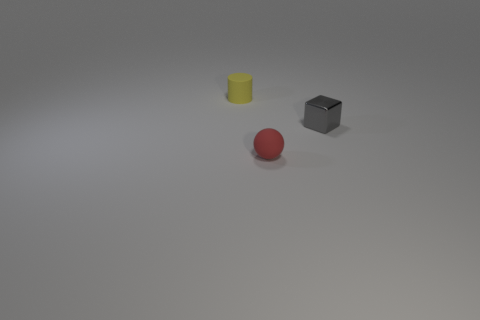The rubber thing that is behind the small metallic cube has what shape?
Keep it short and to the point. Cylinder. How many small objects are both on the left side of the block and right of the red object?
Provide a succinct answer. 0. There is a yellow rubber object; is its size the same as the matte thing in front of the yellow object?
Keep it short and to the point. Yes. There is a rubber thing behind the tiny red matte sphere; what size is it?
Your answer should be very brief. Small. What is the shape of the red thing that is the same material as the yellow cylinder?
Your response must be concise. Sphere. Is the material of the small thing that is right of the tiny matte ball the same as the cylinder?
Provide a succinct answer. No. What number of other things are there of the same material as the red object
Keep it short and to the point. 1. What number of objects are objects that are left of the gray thing or tiny objects that are to the right of the small cylinder?
Make the answer very short. 3. There is a gray thing that is the same size as the ball; what is its shape?
Give a very brief answer. Cube. What number of metallic objects are blocks or small objects?
Make the answer very short. 1. 